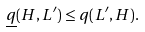Convert formula to latex. <formula><loc_0><loc_0><loc_500><loc_500>\underline { q } ( H , L ^ { \prime } ) \leq q ( L ^ { \prime } , H ) .</formula> 